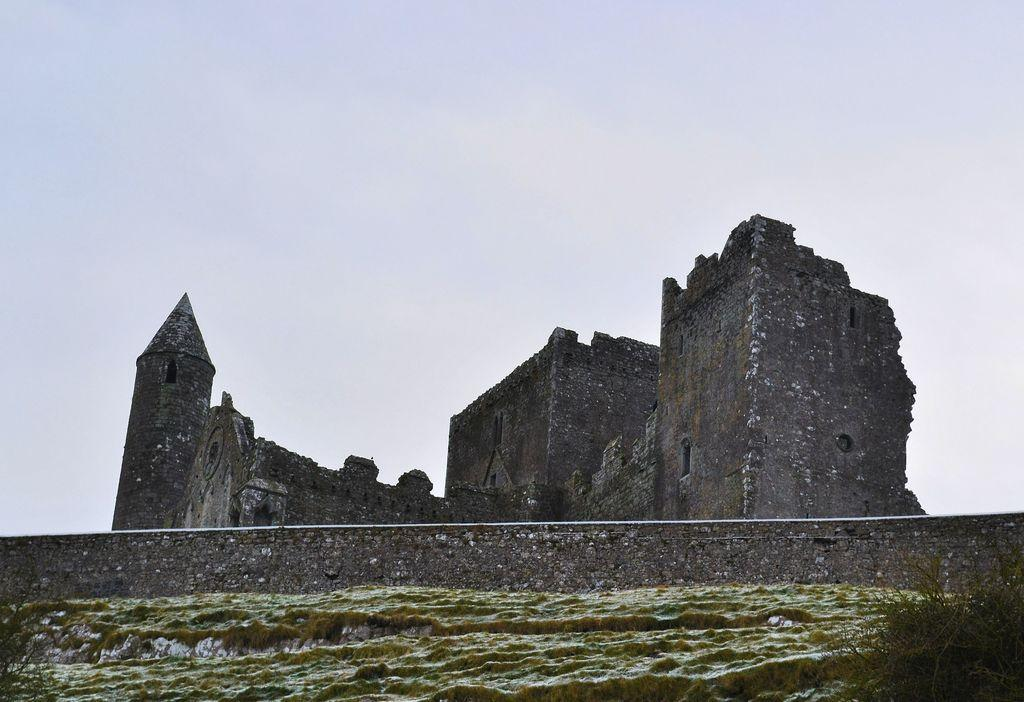What is the main subject of the image? There is a fort at the center of the image. What can be seen in the background of the image? There is a sky visible in the background of the image. Who is the manager of the horses in the image? There are no horses or managers present in the image; it features a fort and a sky. 